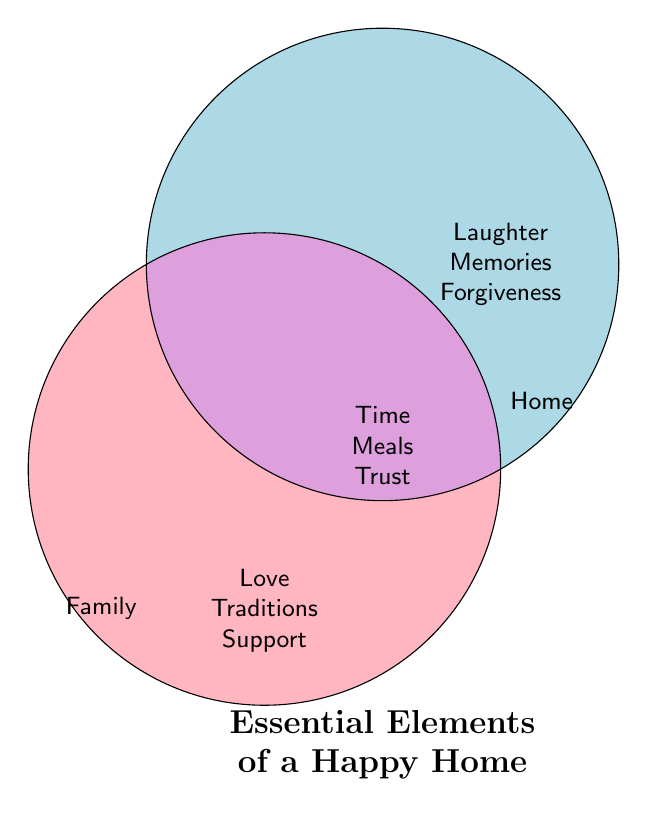What are the titles on the circles? The two circles are labeled with titles that indicate the areas they represent. On the left circle, the title says "Family" and on the right circle, the title says "Home".
Answer: Family, Home What elements are in the intersection of the two circles? The intersection represents shared essential elements between "Family" and "Home". The elements listed in this intersection are Time, Meals, and Trust.
Answer: Time, Meals, Trust Which elements are unique to the "Family" circle? The "Family" circle contains elements that focus on family, which are not shared with "Home". The elements are Love, Traditions, and Support.
Answer: Love, Traditions, Support How many elements are present in the "Home" circle? Counting the elements listed in the "Home" circle reveals three separate items. These items are Laughter, Memories, and Forgiveness.
Answer: 3 Which category has the element "Respect"? This question seeks to identify which group among "Family", "Home", or their intersection contains the element "Respect". "Respect" is listed in the "Family" circle.
Answer: Family Are there more elements in the intersection or in the "Home" circle? The intersection has three elements (Time, Meals, Trust) while the "Home" circle also has three elements (Laughter, Memories, Forgiveness). Both sections have an equal number of elements.
Answer: Equal Compare the number of elements in the "Family" circle to the intersection. By counting, we see the "Family" circle has three elements (Love, Traditions, Support) and the intersection also has three elements (Time, Meals, Trust). Thus, they contain the same number of elements.
Answer: Same What color represents the intersection area? The intersection area, where "Family" and "Home" overlap, is shaded with a light purple color. This color visually distinguishes the shared elements.
Answer: Light purple Which area contains the element "Patience"? This question checks which specific area in the Venn Diagram includes the element "Patience". It is present under the "Family" circle.
Answer: Family What are the essential elements of a happy home listed in the diagram's title? The diagram's title at the bottom summarizes the main concept of the Venn Diagram, listing the most critical elements: Love, Traditions, Support, Laughter, Memories, Forgiveness, Time, Meals, and Trust.
Answer: Love, Traditions, Support, Laughter, Memories, Forgiveness, Time, Meals, Trust 